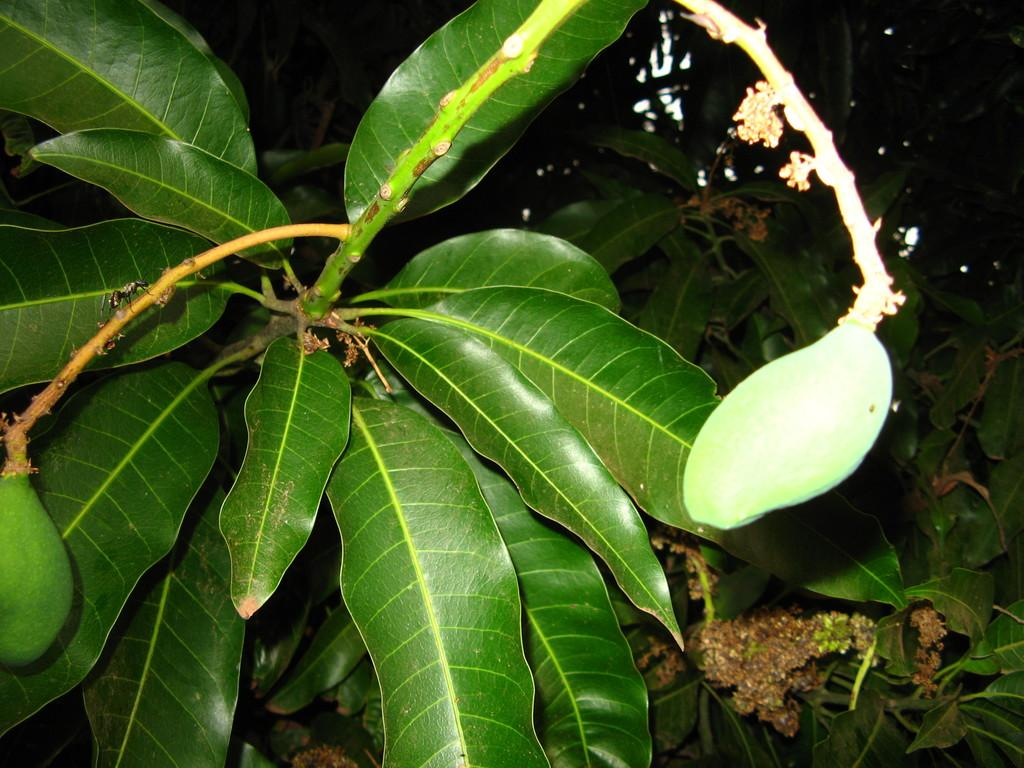What is the main subject of the image? The main subject of the image is a mango tree. What can be seen on the mango tree in the image? Mango fruits and leaves of the mango tree are visible in the image. How many patches can be seen on the toad in the image? There is no toad present in the image; it is a zoom-in of a mango tree. 